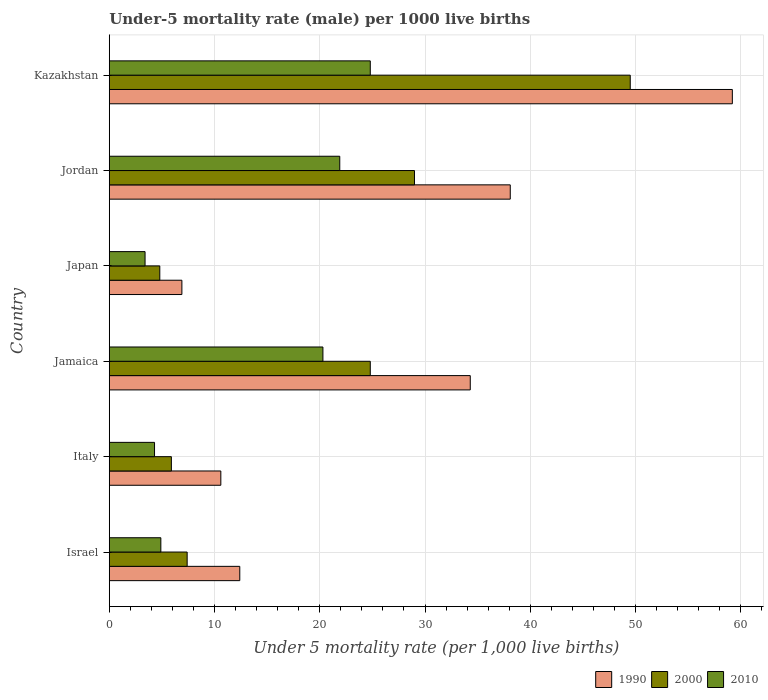How many different coloured bars are there?
Provide a succinct answer. 3. Are the number of bars per tick equal to the number of legend labels?
Offer a very short reply. Yes. How many bars are there on the 2nd tick from the top?
Provide a succinct answer. 3. How many bars are there on the 2nd tick from the bottom?
Give a very brief answer. 3. What is the label of the 2nd group of bars from the top?
Provide a short and direct response. Jordan. In how many cases, is the number of bars for a given country not equal to the number of legend labels?
Make the answer very short. 0. What is the under-five mortality rate in 2000 in Jamaica?
Your answer should be very brief. 24.8. Across all countries, what is the maximum under-five mortality rate in 2000?
Provide a succinct answer. 49.5. Across all countries, what is the minimum under-five mortality rate in 1990?
Your answer should be compact. 6.9. In which country was the under-five mortality rate in 1990 maximum?
Your answer should be very brief. Kazakhstan. In which country was the under-five mortality rate in 1990 minimum?
Make the answer very short. Japan. What is the total under-five mortality rate in 2010 in the graph?
Keep it short and to the point. 79.6. What is the average under-five mortality rate in 2000 per country?
Offer a very short reply. 20.23. What is the difference between the under-five mortality rate in 1990 and under-five mortality rate in 2000 in Japan?
Your answer should be very brief. 2.1. In how many countries, is the under-five mortality rate in 1990 greater than 22 ?
Your response must be concise. 3. What is the ratio of the under-five mortality rate in 1990 in Israel to that in Kazakhstan?
Provide a short and direct response. 0.21. Is the under-five mortality rate in 2010 in Italy less than that in Jamaica?
Your response must be concise. Yes. Is the difference between the under-five mortality rate in 1990 in Israel and Jamaica greater than the difference between the under-five mortality rate in 2000 in Israel and Jamaica?
Your answer should be compact. No. What is the difference between the highest and the second highest under-five mortality rate in 2010?
Offer a terse response. 2.9. What is the difference between the highest and the lowest under-five mortality rate in 2010?
Your answer should be compact. 21.4. In how many countries, is the under-five mortality rate in 1990 greater than the average under-five mortality rate in 1990 taken over all countries?
Ensure brevity in your answer.  3. Are all the bars in the graph horizontal?
Your answer should be compact. Yes. What is the difference between two consecutive major ticks on the X-axis?
Provide a short and direct response. 10. Does the graph contain any zero values?
Offer a terse response. No. Does the graph contain grids?
Your response must be concise. Yes. What is the title of the graph?
Your answer should be compact. Under-5 mortality rate (male) per 1000 live births. What is the label or title of the X-axis?
Offer a very short reply. Under 5 mortality rate (per 1,0 live births). What is the label or title of the Y-axis?
Provide a short and direct response. Country. What is the Under 5 mortality rate (per 1,000 live births) in 2000 in Israel?
Make the answer very short. 7.4. What is the Under 5 mortality rate (per 1,000 live births) of 1990 in Italy?
Ensure brevity in your answer.  10.6. What is the Under 5 mortality rate (per 1,000 live births) of 2010 in Italy?
Your answer should be very brief. 4.3. What is the Under 5 mortality rate (per 1,000 live births) in 1990 in Jamaica?
Offer a terse response. 34.3. What is the Under 5 mortality rate (per 1,000 live births) in 2000 in Jamaica?
Your answer should be compact. 24.8. What is the Under 5 mortality rate (per 1,000 live births) in 2010 in Jamaica?
Provide a succinct answer. 20.3. What is the Under 5 mortality rate (per 1,000 live births) in 1990 in Japan?
Offer a terse response. 6.9. What is the Under 5 mortality rate (per 1,000 live births) in 2000 in Japan?
Your answer should be very brief. 4.8. What is the Under 5 mortality rate (per 1,000 live births) in 2010 in Japan?
Provide a succinct answer. 3.4. What is the Under 5 mortality rate (per 1,000 live births) of 1990 in Jordan?
Your answer should be very brief. 38.1. What is the Under 5 mortality rate (per 1,000 live births) in 2010 in Jordan?
Keep it short and to the point. 21.9. What is the Under 5 mortality rate (per 1,000 live births) of 1990 in Kazakhstan?
Offer a terse response. 59.2. What is the Under 5 mortality rate (per 1,000 live births) of 2000 in Kazakhstan?
Your response must be concise. 49.5. What is the Under 5 mortality rate (per 1,000 live births) in 2010 in Kazakhstan?
Give a very brief answer. 24.8. Across all countries, what is the maximum Under 5 mortality rate (per 1,000 live births) in 1990?
Ensure brevity in your answer.  59.2. Across all countries, what is the maximum Under 5 mortality rate (per 1,000 live births) in 2000?
Ensure brevity in your answer.  49.5. Across all countries, what is the maximum Under 5 mortality rate (per 1,000 live births) of 2010?
Ensure brevity in your answer.  24.8. Across all countries, what is the minimum Under 5 mortality rate (per 1,000 live births) in 1990?
Your answer should be very brief. 6.9. What is the total Under 5 mortality rate (per 1,000 live births) of 1990 in the graph?
Make the answer very short. 161.5. What is the total Under 5 mortality rate (per 1,000 live births) in 2000 in the graph?
Provide a succinct answer. 121.4. What is the total Under 5 mortality rate (per 1,000 live births) in 2010 in the graph?
Your answer should be very brief. 79.6. What is the difference between the Under 5 mortality rate (per 1,000 live births) in 2010 in Israel and that in Italy?
Offer a very short reply. 0.6. What is the difference between the Under 5 mortality rate (per 1,000 live births) of 1990 in Israel and that in Jamaica?
Make the answer very short. -21.9. What is the difference between the Under 5 mortality rate (per 1,000 live births) of 2000 in Israel and that in Jamaica?
Ensure brevity in your answer.  -17.4. What is the difference between the Under 5 mortality rate (per 1,000 live births) of 2010 in Israel and that in Jamaica?
Your response must be concise. -15.4. What is the difference between the Under 5 mortality rate (per 1,000 live births) in 2000 in Israel and that in Japan?
Keep it short and to the point. 2.6. What is the difference between the Under 5 mortality rate (per 1,000 live births) of 2010 in Israel and that in Japan?
Offer a very short reply. 1.5. What is the difference between the Under 5 mortality rate (per 1,000 live births) of 1990 in Israel and that in Jordan?
Offer a terse response. -25.7. What is the difference between the Under 5 mortality rate (per 1,000 live births) of 2000 in Israel and that in Jordan?
Ensure brevity in your answer.  -21.6. What is the difference between the Under 5 mortality rate (per 1,000 live births) in 2010 in Israel and that in Jordan?
Provide a succinct answer. -17. What is the difference between the Under 5 mortality rate (per 1,000 live births) in 1990 in Israel and that in Kazakhstan?
Provide a succinct answer. -46.8. What is the difference between the Under 5 mortality rate (per 1,000 live births) of 2000 in Israel and that in Kazakhstan?
Your answer should be very brief. -42.1. What is the difference between the Under 5 mortality rate (per 1,000 live births) in 2010 in Israel and that in Kazakhstan?
Offer a terse response. -19.9. What is the difference between the Under 5 mortality rate (per 1,000 live births) of 1990 in Italy and that in Jamaica?
Offer a terse response. -23.7. What is the difference between the Under 5 mortality rate (per 1,000 live births) in 2000 in Italy and that in Jamaica?
Keep it short and to the point. -18.9. What is the difference between the Under 5 mortality rate (per 1,000 live births) of 2010 in Italy and that in Jamaica?
Keep it short and to the point. -16. What is the difference between the Under 5 mortality rate (per 1,000 live births) of 1990 in Italy and that in Japan?
Give a very brief answer. 3.7. What is the difference between the Under 5 mortality rate (per 1,000 live births) in 1990 in Italy and that in Jordan?
Offer a very short reply. -27.5. What is the difference between the Under 5 mortality rate (per 1,000 live births) in 2000 in Italy and that in Jordan?
Give a very brief answer. -23.1. What is the difference between the Under 5 mortality rate (per 1,000 live births) in 2010 in Italy and that in Jordan?
Your answer should be compact. -17.6. What is the difference between the Under 5 mortality rate (per 1,000 live births) in 1990 in Italy and that in Kazakhstan?
Make the answer very short. -48.6. What is the difference between the Under 5 mortality rate (per 1,000 live births) in 2000 in Italy and that in Kazakhstan?
Ensure brevity in your answer.  -43.6. What is the difference between the Under 5 mortality rate (per 1,000 live births) of 2010 in Italy and that in Kazakhstan?
Ensure brevity in your answer.  -20.5. What is the difference between the Under 5 mortality rate (per 1,000 live births) in 1990 in Jamaica and that in Japan?
Ensure brevity in your answer.  27.4. What is the difference between the Under 5 mortality rate (per 1,000 live births) in 2000 in Jamaica and that in Jordan?
Ensure brevity in your answer.  -4.2. What is the difference between the Under 5 mortality rate (per 1,000 live births) of 1990 in Jamaica and that in Kazakhstan?
Your answer should be compact. -24.9. What is the difference between the Under 5 mortality rate (per 1,000 live births) in 2000 in Jamaica and that in Kazakhstan?
Provide a succinct answer. -24.7. What is the difference between the Under 5 mortality rate (per 1,000 live births) of 2010 in Jamaica and that in Kazakhstan?
Your answer should be compact. -4.5. What is the difference between the Under 5 mortality rate (per 1,000 live births) of 1990 in Japan and that in Jordan?
Your response must be concise. -31.2. What is the difference between the Under 5 mortality rate (per 1,000 live births) in 2000 in Japan and that in Jordan?
Give a very brief answer. -24.2. What is the difference between the Under 5 mortality rate (per 1,000 live births) in 2010 in Japan and that in Jordan?
Your response must be concise. -18.5. What is the difference between the Under 5 mortality rate (per 1,000 live births) in 1990 in Japan and that in Kazakhstan?
Your answer should be compact. -52.3. What is the difference between the Under 5 mortality rate (per 1,000 live births) in 2000 in Japan and that in Kazakhstan?
Your answer should be very brief. -44.7. What is the difference between the Under 5 mortality rate (per 1,000 live births) of 2010 in Japan and that in Kazakhstan?
Provide a short and direct response. -21.4. What is the difference between the Under 5 mortality rate (per 1,000 live births) of 1990 in Jordan and that in Kazakhstan?
Provide a short and direct response. -21.1. What is the difference between the Under 5 mortality rate (per 1,000 live births) in 2000 in Jordan and that in Kazakhstan?
Offer a terse response. -20.5. What is the difference between the Under 5 mortality rate (per 1,000 live births) in 1990 in Israel and the Under 5 mortality rate (per 1,000 live births) in 2000 in Italy?
Keep it short and to the point. 6.5. What is the difference between the Under 5 mortality rate (per 1,000 live births) of 2000 in Israel and the Under 5 mortality rate (per 1,000 live births) of 2010 in Italy?
Give a very brief answer. 3.1. What is the difference between the Under 5 mortality rate (per 1,000 live births) of 1990 in Israel and the Under 5 mortality rate (per 1,000 live births) of 2000 in Jamaica?
Your answer should be compact. -12.4. What is the difference between the Under 5 mortality rate (per 1,000 live births) in 1990 in Israel and the Under 5 mortality rate (per 1,000 live births) in 2000 in Japan?
Give a very brief answer. 7.6. What is the difference between the Under 5 mortality rate (per 1,000 live births) in 1990 in Israel and the Under 5 mortality rate (per 1,000 live births) in 2010 in Japan?
Provide a succinct answer. 9. What is the difference between the Under 5 mortality rate (per 1,000 live births) in 2000 in Israel and the Under 5 mortality rate (per 1,000 live births) in 2010 in Japan?
Offer a very short reply. 4. What is the difference between the Under 5 mortality rate (per 1,000 live births) of 1990 in Israel and the Under 5 mortality rate (per 1,000 live births) of 2000 in Jordan?
Your answer should be compact. -16.6. What is the difference between the Under 5 mortality rate (per 1,000 live births) of 2000 in Israel and the Under 5 mortality rate (per 1,000 live births) of 2010 in Jordan?
Offer a very short reply. -14.5. What is the difference between the Under 5 mortality rate (per 1,000 live births) in 1990 in Israel and the Under 5 mortality rate (per 1,000 live births) in 2000 in Kazakhstan?
Make the answer very short. -37.1. What is the difference between the Under 5 mortality rate (per 1,000 live births) in 1990 in Israel and the Under 5 mortality rate (per 1,000 live births) in 2010 in Kazakhstan?
Keep it short and to the point. -12.4. What is the difference between the Under 5 mortality rate (per 1,000 live births) in 2000 in Israel and the Under 5 mortality rate (per 1,000 live births) in 2010 in Kazakhstan?
Give a very brief answer. -17.4. What is the difference between the Under 5 mortality rate (per 1,000 live births) in 1990 in Italy and the Under 5 mortality rate (per 1,000 live births) in 2000 in Jamaica?
Provide a short and direct response. -14.2. What is the difference between the Under 5 mortality rate (per 1,000 live births) in 2000 in Italy and the Under 5 mortality rate (per 1,000 live births) in 2010 in Jamaica?
Offer a terse response. -14.4. What is the difference between the Under 5 mortality rate (per 1,000 live births) of 2000 in Italy and the Under 5 mortality rate (per 1,000 live births) of 2010 in Japan?
Make the answer very short. 2.5. What is the difference between the Under 5 mortality rate (per 1,000 live births) in 1990 in Italy and the Under 5 mortality rate (per 1,000 live births) in 2000 in Jordan?
Offer a very short reply. -18.4. What is the difference between the Under 5 mortality rate (per 1,000 live births) of 2000 in Italy and the Under 5 mortality rate (per 1,000 live births) of 2010 in Jordan?
Your answer should be very brief. -16. What is the difference between the Under 5 mortality rate (per 1,000 live births) of 1990 in Italy and the Under 5 mortality rate (per 1,000 live births) of 2000 in Kazakhstan?
Keep it short and to the point. -38.9. What is the difference between the Under 5 mortality rate (per 1,000 live births) in 1990 in Italy and the Under 5 mortality rate (per 1,000 live births) in 2010 in Kazakhstan?
Keep it short and to the point. -14.2. What is the difference between the Under 5 mortality rate (per 1,000 live births) of 2000 in Italy and the Under 5 mortality rate (per 1,000 live births) of 2010 in Kazakhstan?
Keep it short and to the point. -18.9. What is the difference between the Under 5 mortality rate (per 1,000 live births) in 1990 in Jamaica and the Under 5 mortality rate (per 1,000 live births) in 2000 in Japan?
Make the answer very short. 29.5. What is the difference between the Under 5 mortality rate (per 1,000 live births) in 1990 in Jamaica and the Under 5 mortality rate (per 1,000 live births) in 2010 in Japan?
Provide a succinct answer. 30.9. What is the difference between the Under 5 mortality rate (per 1,000 live births) of 2000 in Jamaica and the Under 5 mortality rate (per 1,000 live births) of 2010 in Japan?
Make the answer very short. 21.4. What is the difference between the Under 5 mortality rate (per 1,000 live births) of 1990 in Jamaica and the Under 5 mortality rate (per 1,000 live births) of 2000 in Jordan?
Provide a short and direct response. 5.3. What is the difference between the Under 5 mortality rate (per 1,000 live births) in 1990 in Jamaica and the Under 5 mortality rate (per 1,000 live births) in 2010 in Jordan?
Your response must be concise. 12.4. What is the difference between the Under 5 mortality rate (per 1,000 live births) in 1990 in Jamaica and the Under 5 mortality rate (per 1,000 live births) in 2000 in Kazakhstan?
Your answer should be very brief. -15.2. What is the difference between the Under 5 mortality rate (per 1,000 live births) of 1990 in Jamaica and the Under 5 mortality rate (per 1,000 live births) of 2010 in Kazakhstan?
Provide a succinct answer. 9.5. What is the difference between the Under 5 mortality rate (per 1,000 live births) in 2000 in Jamaica and the Under 5 mortality rate (per 1,000 live births) in 2010 in Kazakhstan?
Your response must be concise. 0. What is the difference between the Under 5 mortality rate (per 1,000 live births) of 1990 in Japan and the Under 5 mortality rate (per 1,000 live births) of 2000 in Jordan?
Ensure brevity in your answer.  -22.1. What is the difference between the Under 5 mortality rate (per 1,000 live births) in 2000 in Japan and the Under 5 mortality rate (per 1,000 live births) in 2010 in Jordan?
Make the answer very short. -17.1. What is the difference between the Under 5 mortality rate (per 1,000 live births) in 1990 in Japan and the Under 5 mortality rate (per 1,000 live births) in 2000 in Kazakhstan?
Ensure brevity in your answer.  -42.6. What is the difference between the Under 5 mortality rate (per 1,000 live births) of 1990 in Japan and the Under 5 mortality rate (per 1,000 live births) of 2010 in Kazakhstan?
Provide a short and direct response. -17.9. What is the difference between the Under 5 mortality rate (per 1,000 live births) of 2000 in Jordan and the Under 5 mortality rate (per 1,000 live births) of 2010 in Kazakhstan?
Your answer should be very brief. 4.2. What is the average Under 5 mortality rate (per 1,000 live births) of 1990 per country?
Offer a terse response. 26.92. What is the average Under 5 mortality rate (per 1,000 live births) of 2000 per country?
Your answer should be very brief. 20.23. What is the average Under 5 mortality rate (per 1,000 live births) in 2010 per country?
Give a very brief answer. 13.27. What is the difference between the Under 5 mortality rate (per 1,000 live births) in 1990 and Under 5 mortality rate (per 1,000 live births) in 2000 in Israel?
Provide a succinct answer. 5. What is the difference between the Under 5 mortality rate (per 1,000 live births) of 1990 and Under 5 mortality rate (per 1,000 live births) of 2010 in Israel?
Provide a succinct answer. 7.5. What is the difference between the Under 5 mortality rate (per 1,000 live births) of 1990 and Under 5 mortality rate (per 1,000 live births) of 2000 in Italy?
Provide a short and direct response. 4.7. What is the difference between the Under 5 mortality rate (per 1,000 live births) of 1990 and Under 5 mortality rate (per 1,000 live births) of 2010 in Italy?
Your answer should be very brief. 6.3. What is the difference between the Under 5 mortality rate (per 1,000 live births) of 2000 and Under 5 mortality rate (per 1,000 live births) of 2010 in Jamaica?
Offer a terse response. 4.5. What is the difference between the Under 5 mortality rate (per 1,000 live births) of 2000 and Under 5 mortality rate (per 1,000 live births) of 2010 in Japan?
Make the answer very short. 1.4. What is the difference between the Under 5 mortality rate (per 1,000 live births) in 1990 and Under 5 mortality rate (per 1,000 live births) in 2000 in Jordan?
Offer a very short reply. 9.1. What is the difference between the Under 5 mortality rate (per 1,000 live births) of 2000 and Under 5 mortality rate (per 1,000 live births) of 2010 in Jordan?
Provide a short and direct response. 7.1. What is the difference between the Under 5 mortality rate (per 1,000 live births) in 1990 and Under 5 mortality rate (per 1,000 live births) in 2000 in Kazakhstan?
Your answer should be very brief. 9.7. What is the difference between the Under 5 mortality rate (per 1,000 live births) in 1990 and Under 5 mortality rate (per 1,000 live births) in 2010 in Kazakhstan?
Your answer should be very brief. 34.4. What is the difference between the Under 5 mortality rate (per 1,000 live births) of 2000 and Under 5 mortality rate (per 1,000 live births) of 2010 in Kazakhstan?
Provide a succinct answer. 24.7. What is the ratio of the Under 5 mortality rate (per 1,000 live births) of 1990 in Israel to that in Italy?
Provide a succinct answer. 1.17. What is the ratio of the Under 5 mortality rate (per 1,000 live births) in 2000 in Israel to that in Italy?
Ensure brevity in your answer.  1.25. What is the ratio of the Under 5 mortality rate (per 1,000 live births) of 2010 in Israel to that in Italy?
Offer a very short reply. 1.14. What is the ratio of the Under 5 mortality rate (per 1,000 live births) in 1990 in Israel to that in Jamaica?
Offer a very short reply. 0.36. What is the ratio of the Under 5 mortality rate (per 1,000 live births) in 2000 in Israel to that in Jamaica?
Your answer should be very brief. 0.3. What is the ratio of the Under 5 mortality rate (per 1,000 live births) of 2010 in Israel to that in Jamaica?
Ensure brevity in your answer.  0.24. What is the ratio of the Under 5 mortality rate (per 1,000 live births) in 1990 in Israel to that in Japan?
Provide a succinct answer. 1.8. What is the ratio of the Under 5 mortality rate (per 1,000 live births) of 2000 in Israel to that in Japan?
Provide a short and direct response. 1.54. What is the ratio of the Under 5 mortality rate (per 1,000 live births) of 2010 in Israel to that in Japan?
Provide a succinct answer. 1.44. What is the ratio of the Under 5 mortality rate (per 1,000 live births) in 1990 in Israel to that in Jordan?
Keep it short and to the point. 0.33. What is the ratio of the Under 5 mortality rate (per 1,000 live births) of 2000 in Israel to that in Jordan?
Offer a very short reply. 0.26. What is the ratio of the Under 5 mortality rate (per 1,000 live births) of 2010 in Israel to that in Jordan?
Ensure brevity in your answer.  0.22. What is the ratio of the Under 5 mortality rate (per 1,000 live births) of 1990 in Israel to that in Kazakhstan?
Make the answer very short. 0.21. What is the ratio of the Under 5 mortality rate (per 1,000 live births) of 2000 in Israel to that in Kazakhstan?
Offer a very short reply. 0.15. What is the ratio of the Under 5 mortality rate (per 1,000 live births) in 2010 in Israel to that in Kazakhstan?
Ensure brevity in your answer.  0.2. What is the ratio of the Under 5 mortality rate (per 1,000 live births) in 1990 in Italy to that in Jamaica?
Make the answer very short. 0.31. What is the ratio of the Under 5 mortality rate (per 1,000 live births) of 2000 in Italy to that in Jamaica?
Offer a very short reply. 0.24. What is the ratio of the Under 5 mortality rate (per 1,000 live births) in 2010 in Italy to that in Jamaica?
Make the answer very short. 0.21. What is the ratio of the Under 5 mortality rate (per 1,000 live births) in 1990 in Italy to that in Japan?
Keep it short and to the point. 1.54. What is the ratio of the Under 5 mortality rate (per 1,000 live births) of 2000 in Italy to that in Japan?
Keep it short and to the point. 1.23. What is the ratio of the Under 5 mortality rate (per 1,000 live births) in 2010 in Italy to that in Japan?
Offer a terse response. 1.26. What is the ratio of the Under 5 mortality rate (per 1,000 live births) of 1990 in Italy to that in Jordan?
Make the answer very short. 0.28. What is the ratio of the Under 5 mortality rate (per 1,000 live births) of 2000 in Italy to that in Jordan?
Provide a succinct answer. 0.2. What is the ratio of the Under 5 mortality rate (per 1,000 live births) in 2010 in Italy to that in Jordan?
Keep it short and to the point. 0.2. What is the ratio of the Under 5 mortality rate (per 1,000 live births) of 1990 in Italy to that in Kazakhstan?
Offer a very short reply. 0.18. What is the ratio of the Under 5 mortality rate (per 1,000 live births) in 2000 in Italy to that in Kazakhstan?
Give a very brief answer. 0.12. What is the ratio of the Under 5 mortality rate (per 1,000 live births) of 2010 in Italy to that in Kazakhstan?
Provide a succinct answer. 0.17. What is the ratio of the Under 5 mortality rate (per 1,000 live births) in 1990 in Jamaica to that in Japan?
Offer a very short reply. 4.97. What is the ratio of the Under 5 mortality rate (per 1,000 live births) in 2000 in Jamaica to that in Japan?
Provide a short and direct response. 5.17. What is the ratio of the Under 5 mortality rate (per 1,000 live births) of 2010 in Jamaica to that in Japan?
Your answer should be very brief. 5.97. What is the ratio of the Under 5 mortality rate (per 1,000 live births) in 1990 in Jamaica to that in Jordan?
Ensure brevity in your answer.  0.9. What is the ratio of the Under 5 mortality rate (per 1,000 live births) in 2000 in Jamaica to that in Jordan?
Offer a very short reply. 0.86. What is the ratio of the Under 5 mortality rate (per 1,000 live births) in 2010 in Jamaica to that in Jordan?
Keep it short and to the point. 0.93. What is the ratio of the Under 5 mortality rate (per 1,000 live births) of 1990 in Jamaica to that in Kazakhstan?
Your answer should be compact. 0.58. What is the ratio of the Under 5 mortality rate (per 1,000 live births) of 2000 in Jamaica to that in Kazakhstan?
Your response must be concise. 0.5. What is the ratio of the Under 5 mortality rate (per 1,000 live births) of 2010 in Jamaica to that in Kazakhstan?
Give a very brief answer. 0.82. What is the ratio of the Under 5 mortality rate (per 1,000 live births) in 1990 in Japan to that in Jordan?
Provide a succinct answer. 0.18. What is the ratio of the Under 5 mortality rate (per 1,000 live births) in 2000 in Japan to that in Jordan?
Your answer should be compact. 0.17. What is the ratio of the Under 5 mortality rate (per 1,000 live births) in 2010 in Japan to that in Jordan?
Make the answer very short. 0.16. What is the ratio of the Under 5 mortality rate (per 1,000 live births) in 1990 in Japan to that in Kazakhstan?
Provide a succinct answer. 0.12. What is the ratio of the Under 5 mortality rate (per 1,000 live births) of 2000 in Japan to that in Kazakhstan?
Offer a very short reply. 0.1. What is the ratio of the Under 5 mortality rate (per 1,000 live births) in 2010 in Japan to that in Kazakhstan?
Keep it short and to the point. 0.14. What is the ratio of the Under 5 mortality rate (per 1,000 live births) of 1990 in Jordan to that in Kazakhstan?
Your answer should be very brief. 0.64. What is the ratio of the Under 5 mortality rate (per 1,000 live births) of 2000 in Jordan to that in Kazakhstan?
Ensure brevity in your answer.  0.59. What is the ratio of the Under 5 mortality rate (per 1,000 live births) in 2010 in Jordan to that in Kazakhstan?
Provide a short and direct response. 0.88. What is the difference between the highest and the second highest Under 5 mortality rate (per 1,000 live births) in 1990?
Offer a very short reply. 21.1. What is the difference between the highest and the second highest Under 5 mortality rate (per 1,000 live births) in 2000?
Give a very brief answer. 20.5. What is the difference between the highest and the lowest Under 5 mortality rate (per 1,000 live births) of 1990?
Give a very brief answer. 52.3. What is the difference between the highest and the lowest Under 5 mortality rate (per 1,000 live births) of 2000?
Ensure brevity in your answer.  44.7. What is the difference between the highest and the lowest Under 5 mortality rate (per 1,000 live births) of 2010?
Provide a succinct answer. 21.4. 